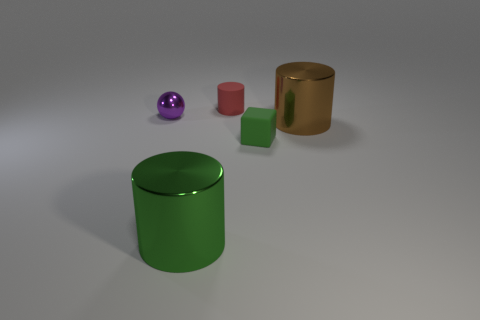Are there any red rubber cylinders that are on the right side of the matte object behind the matte block?
Your answer should be very brief. No. Is there a small cyan object made of the same material as the tiny cylinder?
Ensure brevity in your answer.  No. There is a big cylinder that is to the right of the metal cylinder that is to the left of the small rubber cylinder; what is it made of?
Offer a terse response. Metal. The object that is in front of the brown shiny thing and to the left of the small matte block is made of what material?
Your response must be concise. Metal. Are there an equal number of large green metallic cylinders to the right of the red rubber cylinder and brown objects?
Your response must be concise. No. How many other small things are the same shape as the small red rubber thing?
Offer a terse response. 0. There is a thing that is in front of the green rubber cube that is right of the metallic thing left of the large green shiny thing; what is its size?
Ensure brevity in your answer.  Large. Does the big brown cylinder in front of the small purple ball have the same material as the block?
Your answer should be very brief. No. Are there the same number of tiny green things that are on the left side of the matte cylinder and brown cylinders on the left side of the tiny green block?
Provide a succinct answer. Yes. Is there anything else that is the same size as the metal ball?
Make the answer very short. Yes. 